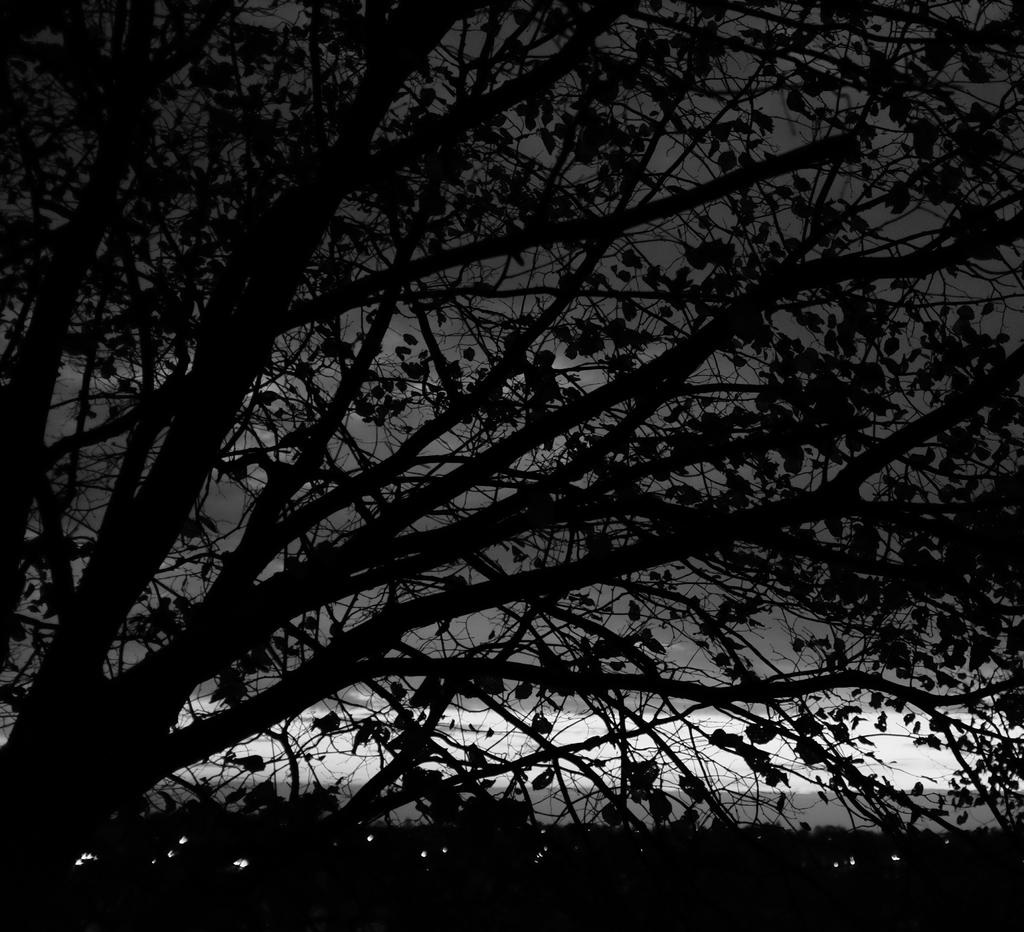What time of day was the image taken? The image was taken during night time. What natural element can be seen in the image? There is a tree in the image. What type of songs can be heard in the image? There are no songs present in the image, as it is a still photograph. How many men are visible in the image? There is no mention of men in the provided facts, so we cannot determine the number of men present in the image. 